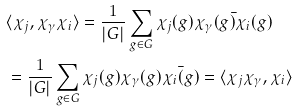<formula> <loc_0><loc_0><loc_500><loc_500>& \langle \chi _ { j } , \chi _ { \gamma } \chi _ { i } \rangle = \frac { 1 } { | G | } \sum _ { g \in G } \chi _ { j } ( g ) \bar { \chi _ { \gamma } ( g ) \chi _ { i } ( g ) } \\ & = \frac { 1 } { | G | } \sum _ { g \in G } \chi _ { j } ( g ) \chi _ { \gamma } ( g ) \bar { \chi _ { i } ( g ) } = \langle \chi _ { j } \chi _ { \gamma } , \chi _ { i } \rangle</formula> 